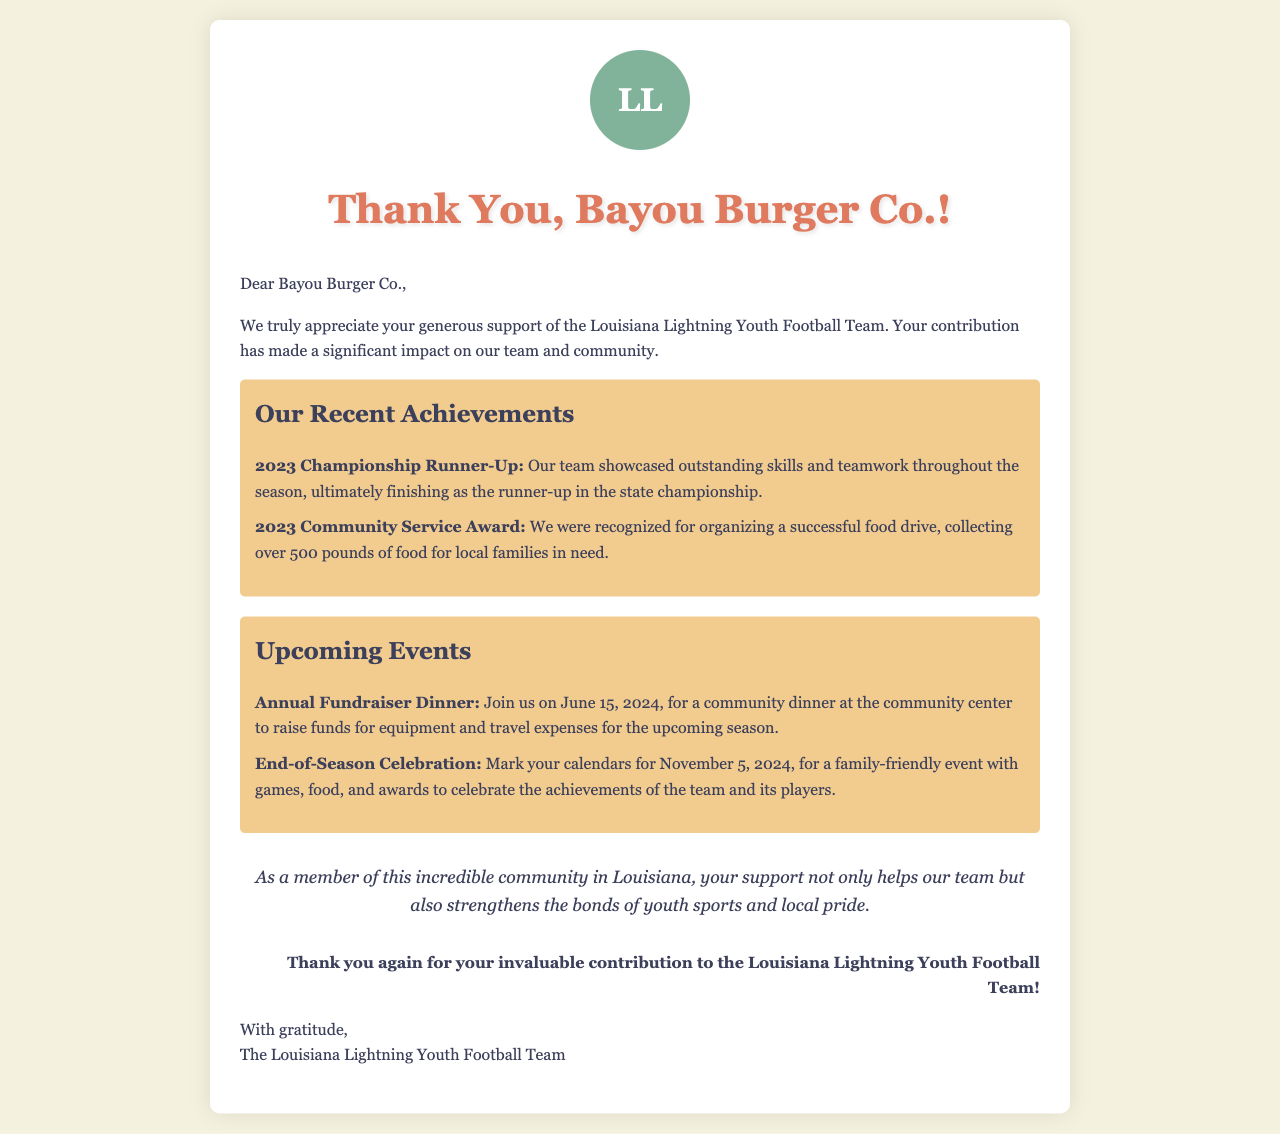What is the name of the team? The team is called the Louisiana Lightning Youth Football Team, as mentioned in the letter's greeting and closing.
Answer: Louisiana Lightning Youth Football Team Who is the recipient of the letter? The letter is addressed to Bayou Burger Co., as indicated in the greeting.
Answer: Bayou Burger Co What award did the team receive in 2023? The team was recognized with the 2023 Community Service Award for organizing a successful food drive.
Answer: 2023 Community Service Award What is the date of the Annual Fundraiser Dinner? The letter states that the Annual Fundraiser Dinner will be held on June 15, 2024.
Answer: June 15, 2024 How much food was collected during the food drive? The food drive resulted in over 500 pounds of food being collected for local families.
Answer: over 500 pounds What event will take place on November 5, 2024? The End-of-Season Celebration is scheduled for November 5, 2024, to celebrate team achievements.
Answer: End-of-Season Celebration What impact did the sponsorship have on the team? The letter expresses that the sponsorship significantly impacted the team and community, emphasizing support and bonding through youth sports.
Answer: significant impact What is the closing sentiment of the letter? The closing expresses gratitude towards Bayou Burger Co. for their contribution to the youth football team.
Answer: Thank you again for your invaluable contribution 